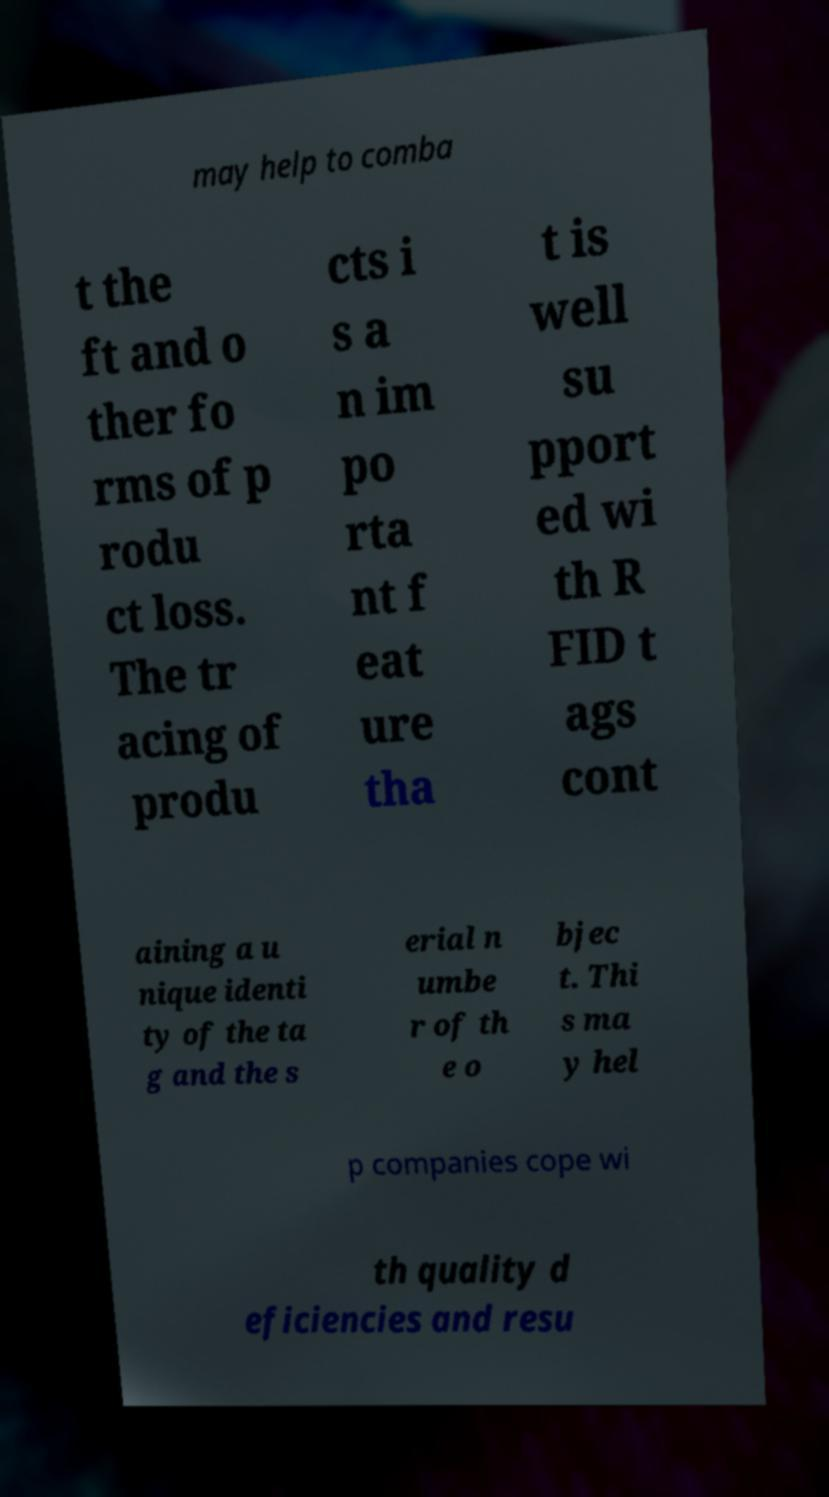Could you assist in decoding the text presented in this image and type it out clearly? may help to comba t the ft and o ther fo rms of p rodu ct loss. The tr acing of produ cts i s a n im po rta nt f eat ure tha t is well su pport ed wi th R FID t ags cont aining a u nique identi ty of the ta g and the s erial n umbe r of th e o bjec t. Thi s ma y hel p companies cope wi th quality d eficiencies and resu 